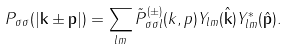Convert formula to latex. <formula><loc_0><loc_0><loc_500><loc_500>P _ { \sigma \sigma } ( | { \mathbf k } \pm { \mathbf p } | ) = \sum _ { l m } \tilde { P } _ { \sigma \sigma l } ^ { ( \pm ) } ( k , p ) Y _ { l m } ( \hat { \mathbf k } ) Y _ { l m } ^ { \ast } ( \hat { \mathbf p } ) .</formula> 